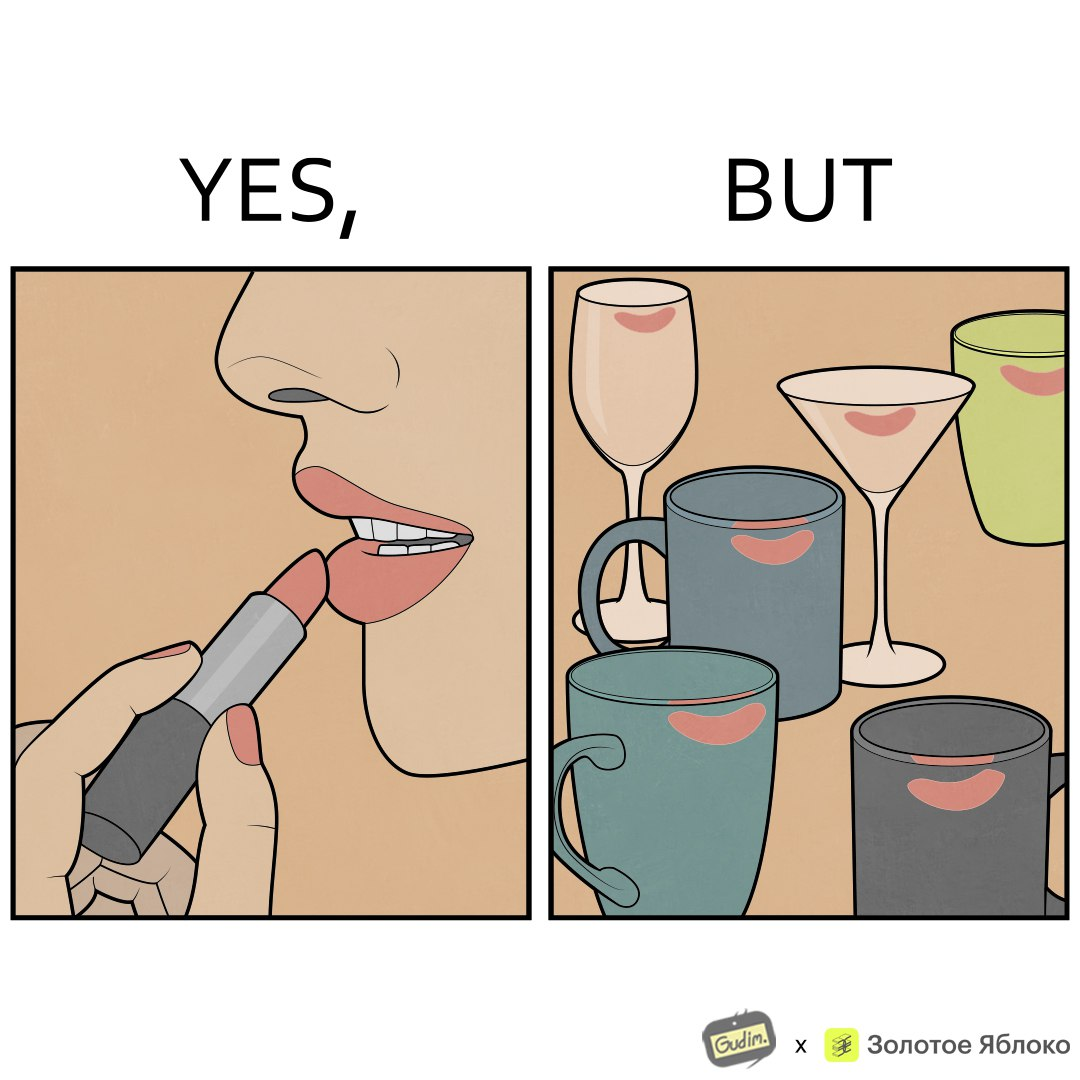Compare the left and right sides of this image. In the left part of the image: a person applying lipstick, probably a girl or woman In the right part of the image: lipstick stains on various mugs and glasses 